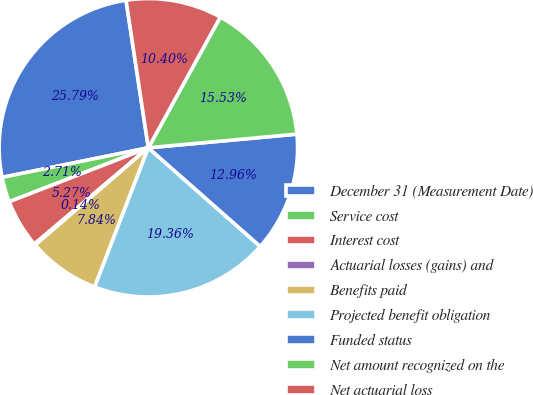<chart> <loc_0><loc_0><loc_500><loc_500><pie_chart><fcel>December 31 (Measurement Date)<fcel>Service cost<fcel>Interest cost<fcel>Actuarial losses (gains) and<fcel>Benefits paid<fcel>Projected benefit obligation<fcel>Funded status<fcel>Net amount recognized on the<fcel>Net actuarial loss<nl><fcel>25.79%<fcel>2.71%<fcel>5.27%<fcel>0.14%<fcel>7.84%<fcel>19.36%<fcel>12.96%<fcel>15.53%<fcel>10.4%<nl></chart> 